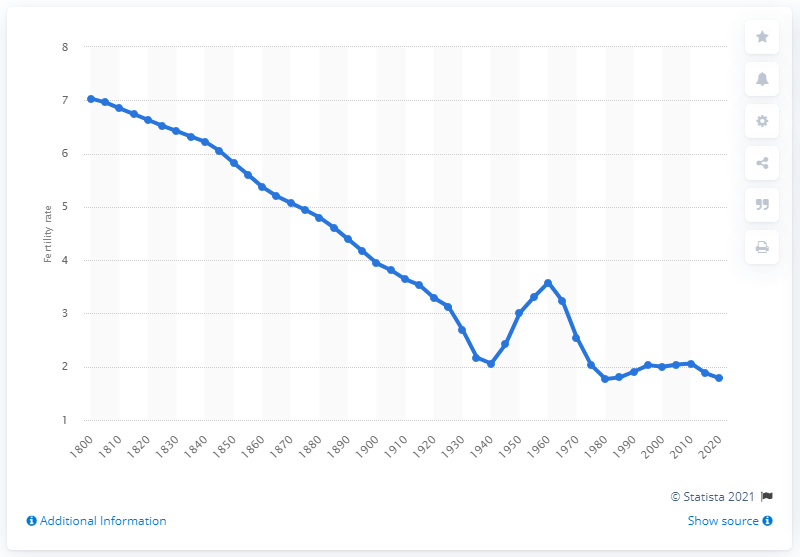Mention a couple of crucial points in this snapshot. According to data from the United States, fertility reached its lowest point in 1980. 